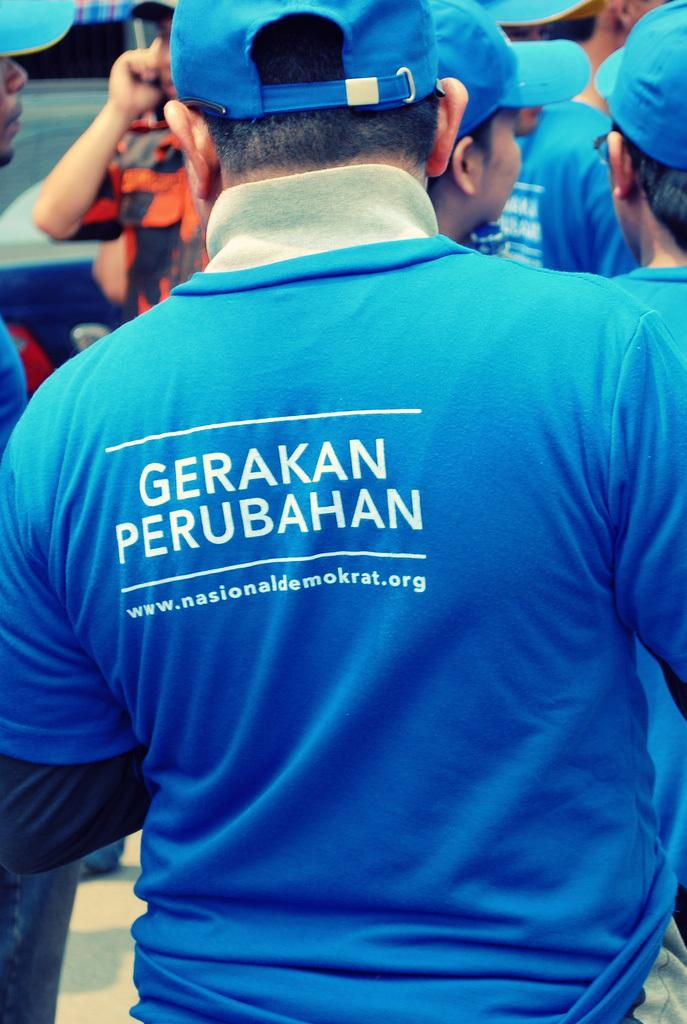Provide a one-sentence caption for the provided image. A stocky man wearing a blue shirt has the words Gerakan Perubahan on his back. 